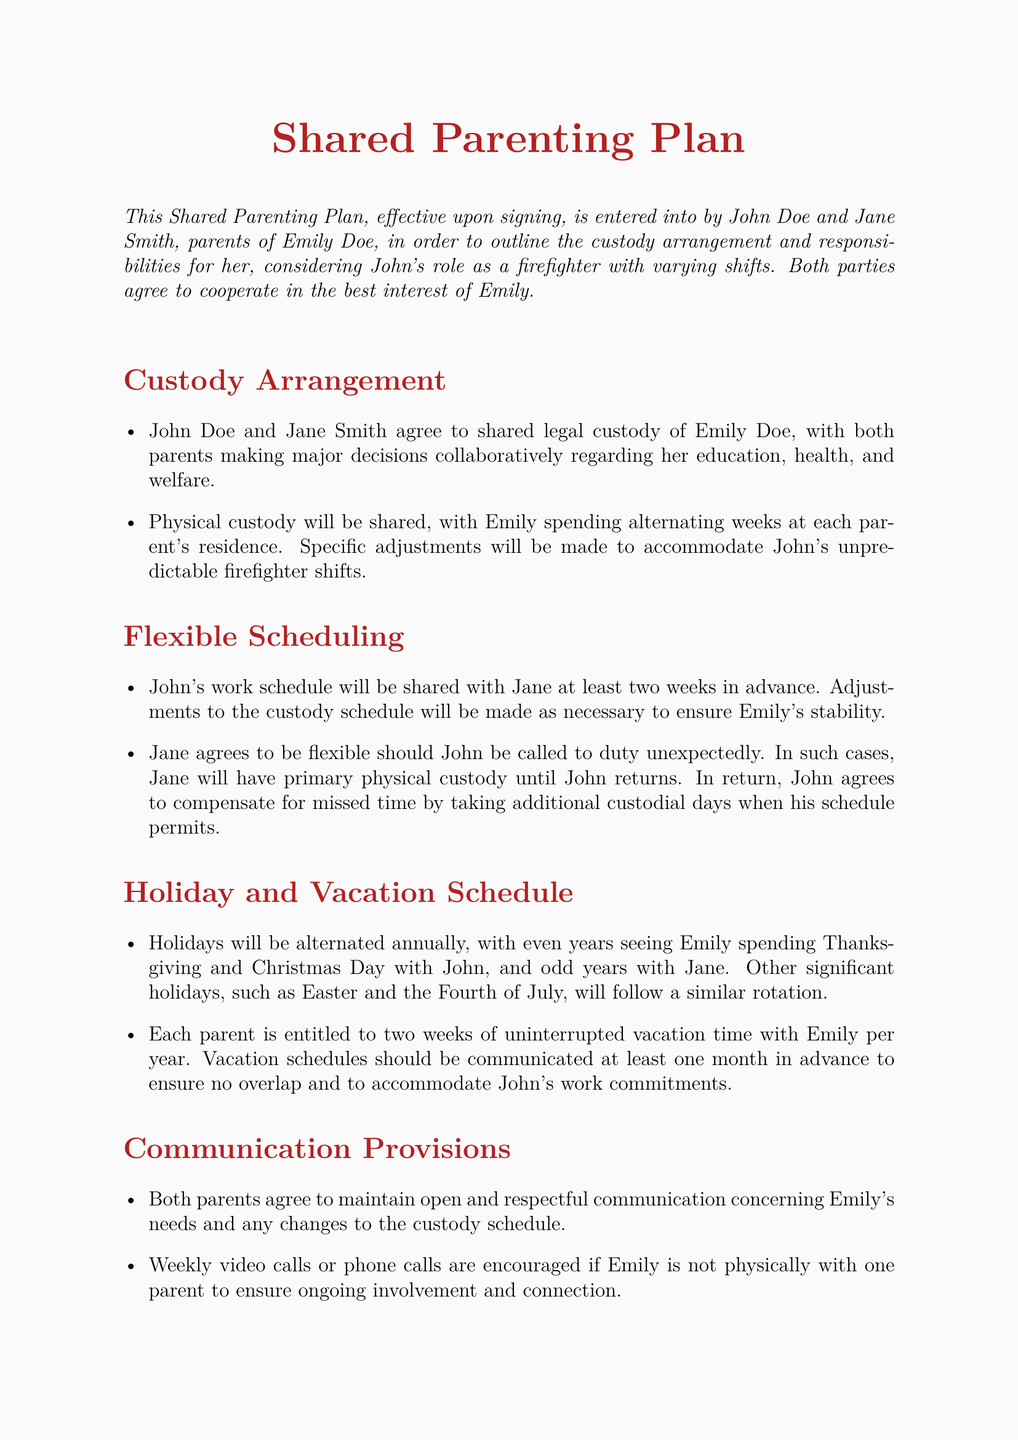What is the name of the child in the custody arrangement? The name of the child, as mentioned in the document, is Emily Doe.
Answer: Emily Doe Who are the parents involved in this shared parenting plan? The parents identified in the document are John Doe and Jane Smith.
Answer: John Doe and Jane Smith How often will the parents share legal custody? The document states that both parents will have shared legal custody of Emily Doe.
Answer: Shared legal custody What is the vacation notification period for the parents? Each parent must communicate their vacation schedules at least one month in advance.
Answer: One month What happens if John is called to duty unexpectedly? In cases where John is called to duty unexpectedly, Jane will have primary physical custody until John's return.
Answer: Jane will have primary custody How are holidays shared according to the plan? Holidays will be alternated annually between the two parents.
Answer: Alternated annually What is the mediation time frame for disputes? The document specifies that a mediator will be selected within one week of a dispute arising.
Answer: One week What kind of communication is encouraged when Emily is with one parent? The document encourages weekly video calls or phone calls to maintain connection with Emily.
Answer: Weekly video calls or phone calls 